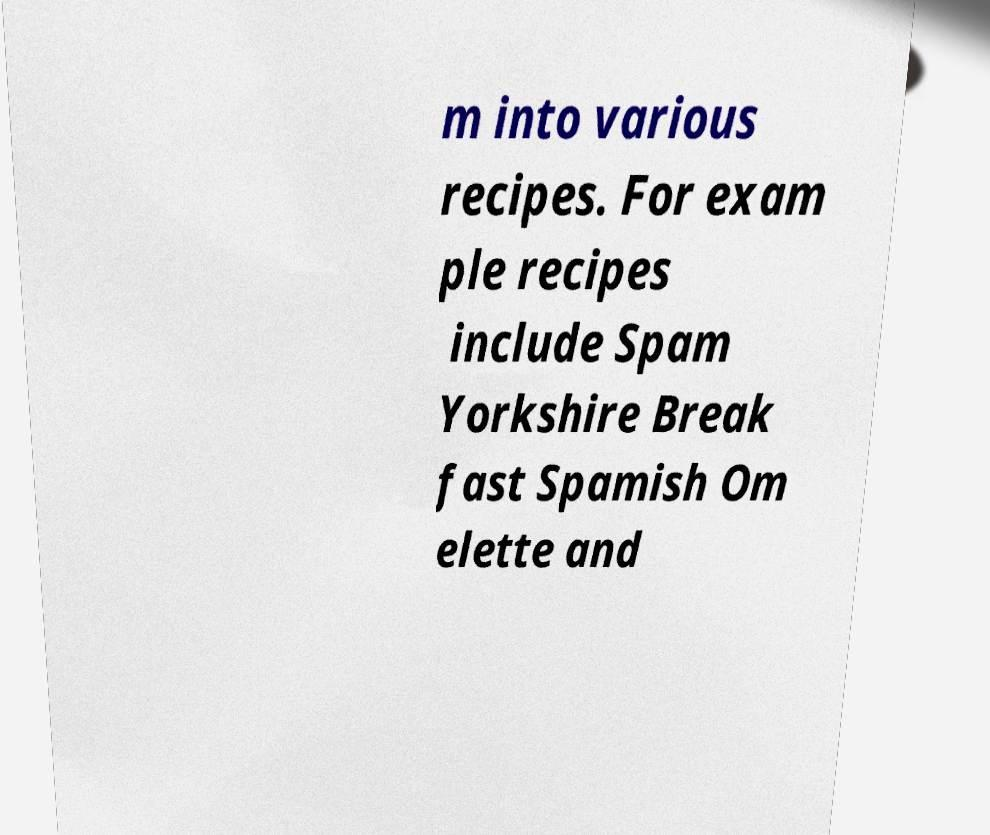I need the written content from this picture converted into text. Can you do that? m into various recipes. For exam ple recipes include Spam Yorkshire Break fast Spamish Om elette and 